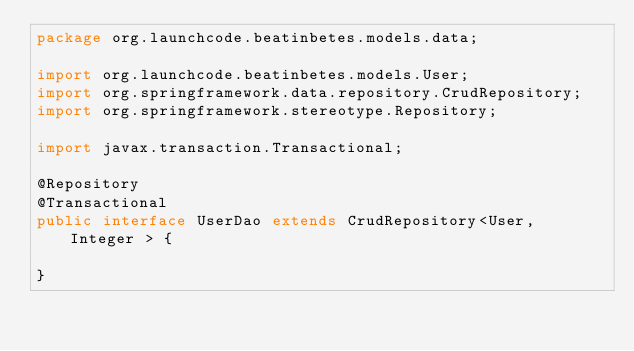Convert code to text. <code><loc_0><loc_0><loc_500><loc_500><_Java_>package org.launchcode.beatinbetes.models.data;

import org.launchcode.beatinbetes.models.User;
import org.springframework.data.repository.CrudRepository;
import org.springframework.stereotype.Repository;

import javax.transaction.Transactional;

@Repository
@Transactional
public interface UserDao extends CrudRepository<User, Integer > {

}
</code> 